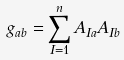<formula> <loc_0><loc_0><loc_500><loc_500>g _ { a b } = \sum _ { I = 1 } ^ { n } A _ { I a } A _ { I b }</formula> 